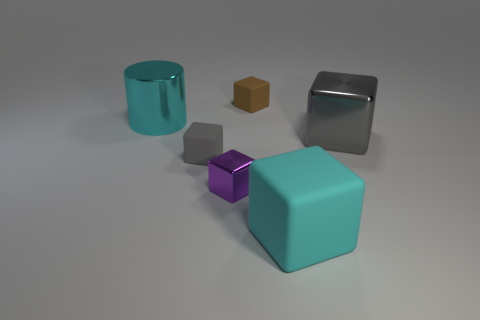Subtract all large gray blocks. How many blocks are left? 4 Add 2 large metal things. How many objects exist? 8 Subtract all gray cubes. How many cubes are left? 3 Subtract 1 cylinders. How many cylinders are left? 0 Add 1 small brown things. How many small brown things are left? 2 Add 6 big cyan rubber blocks. How many big cyan rubber blocks exist? 7 Subtract 0 green cylinders. How many objects are left? 6 Subtract all cubes. How many objects are left? 1 Subtract all cyan cubes. Subtract all gray spheres. How many cubes are left? 4 Subtract all gray spheres. How many red cylinders are left? 0 